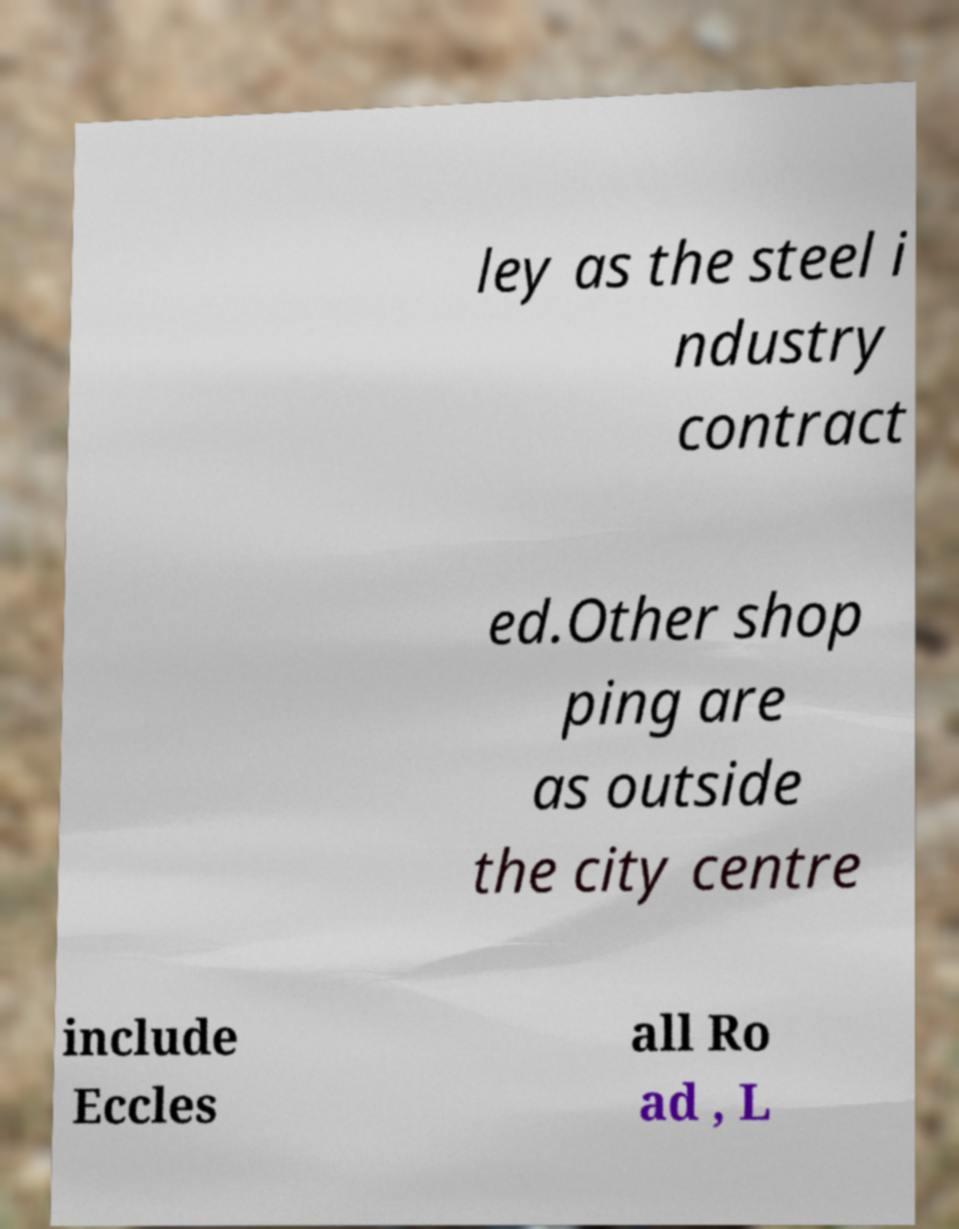I need the written content from this picture converted into text. Can you do that? ley as the steel i ndustry contract ed.Other shop ping are as outside the city centre include Eccles all Ro ad , L 